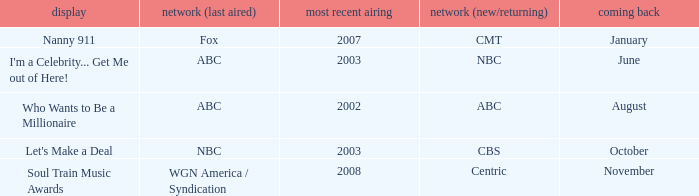When did soul train music awards return? November. 